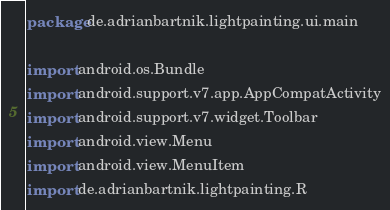<code> <loc_0><loc_0><loc_500><loc_500><_Kotlin_>package de.adrianbartnik.lightpainting.ui.main

import android.os.Bundle
import android.support.v7.app.AppCompatActivity
import android.support.v7.widget.Toolbar
import android.view.Menu
import android.view.MenuItem
import de.adrianbartnik.lightpainting.R</code> 